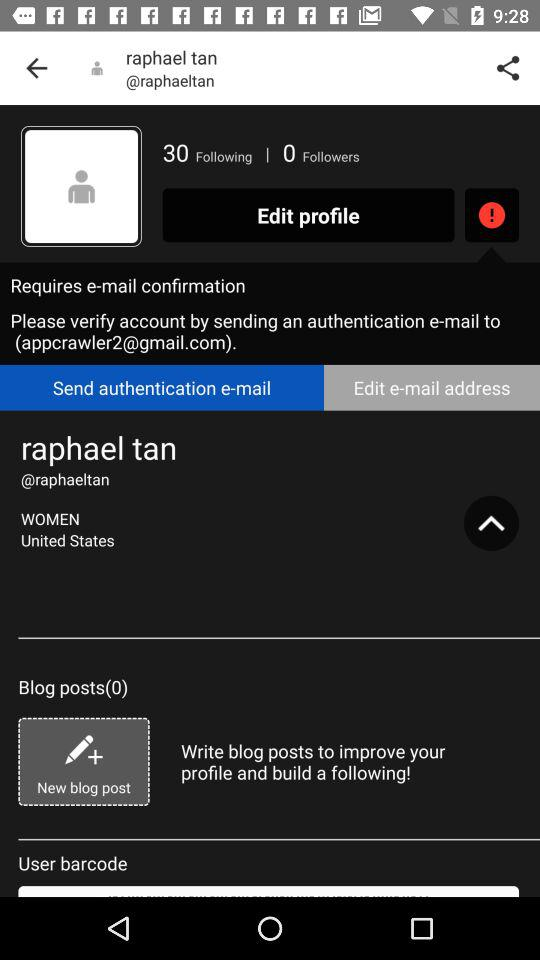How many followers does the user have?
Answer the question using a single word or phrase. 0 